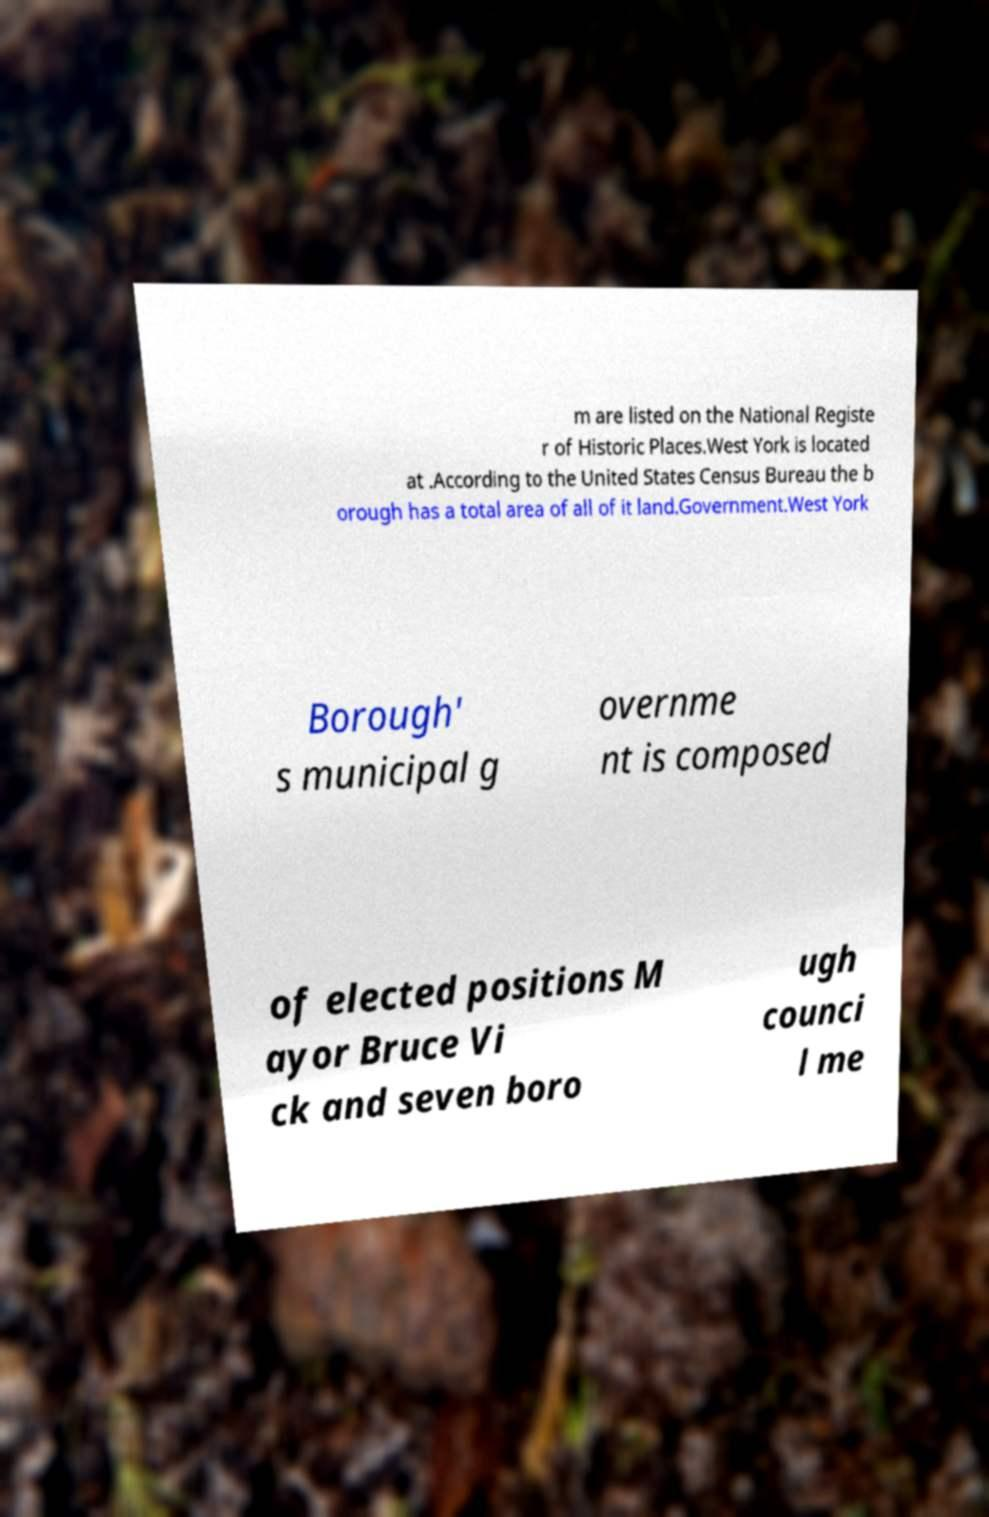Could you extract and type out the text from this image? m are listed on the National Registe r of Historic Places.West York is located at .According to the United States Census Bureau the b orough has a total area of all of it land.Government.West York Borough' s municipal g overnme nt is composed of elected positions M ayor Bruce Vi ck and seven boro ugh counci l me 